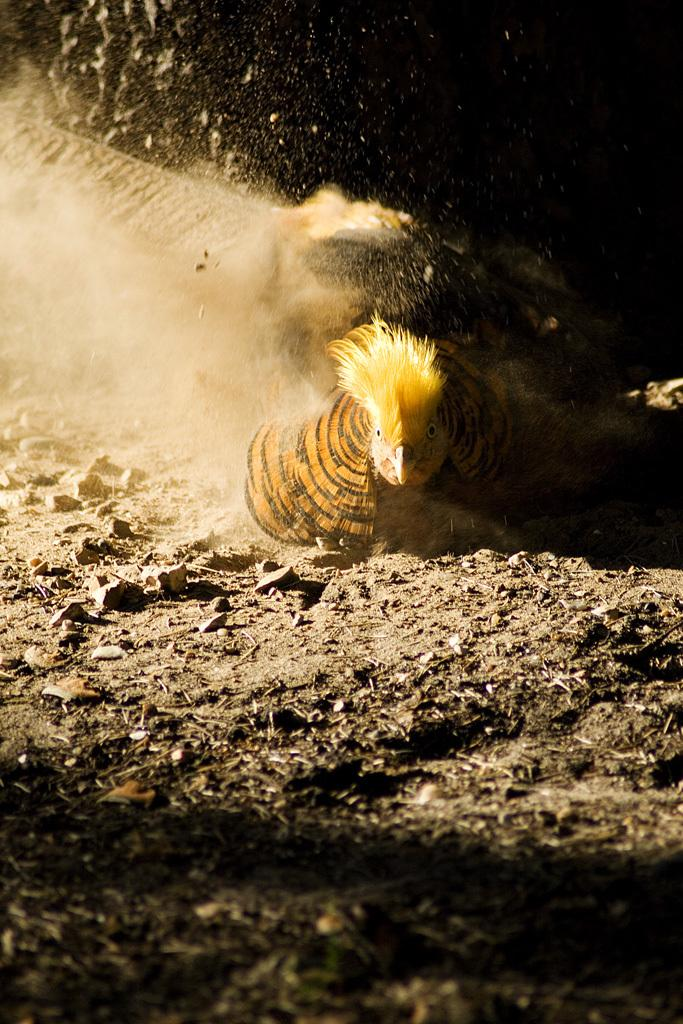What type of animal is present in the image? There is a hen in the image. Where is the hen located in the image? The hen is sitting on the ground. What type of connection is the hen using to communicate with the pest in the image? There is no pest present in the image, and the hen is not using any connection to communicate. 